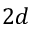<formula> <loc_0><loc_0><loc_500><loc_500>2 d</formula> 